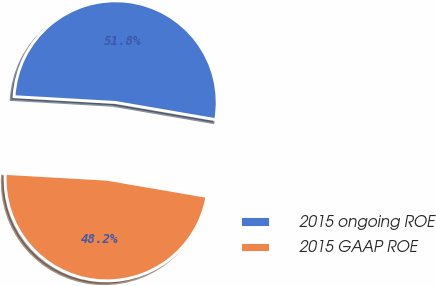Convert chart. <chart><loc_0><loc_0><loc_500><loc_500><pie_chart><fcel>2015 ongoing ROE<fcel>2015 GAAP ROE<nl><fcel>51.8%<fcel>48.2%<nl></chart> 